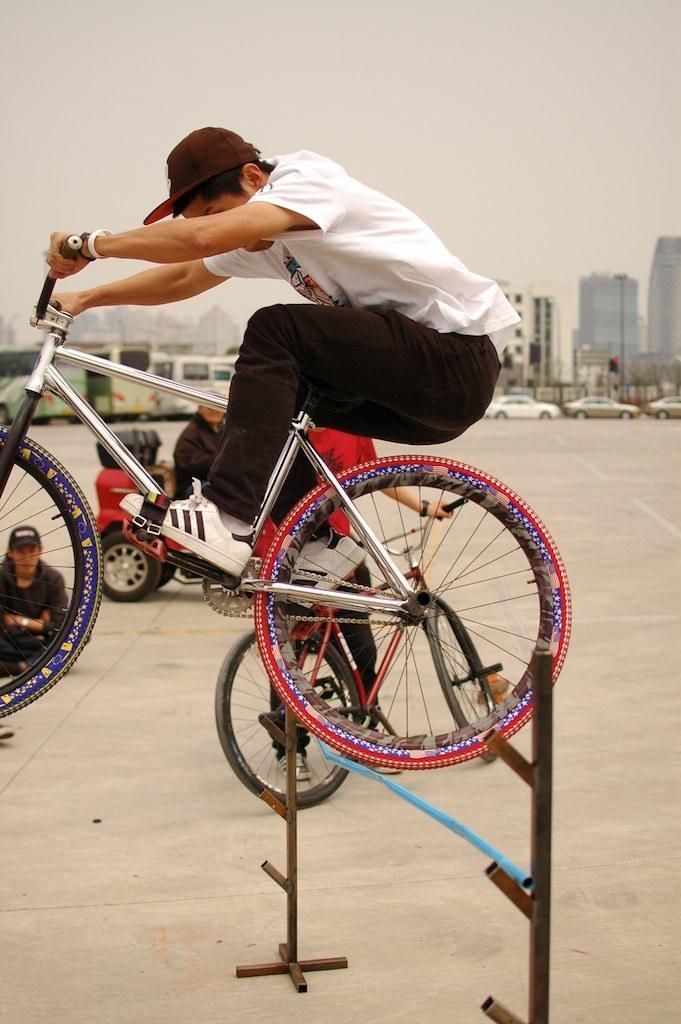In one or two sentences, can you explain what this image depicts? In this image we can see a person sitting on a bicycle which is on the stand. On the backside we can see a person riding bicycle, a person sitting in a vehicle and a person sitting on the ground. We can also see a group of cars and buses parked aside, a board, some buildings and the sky which looks cloudy. 